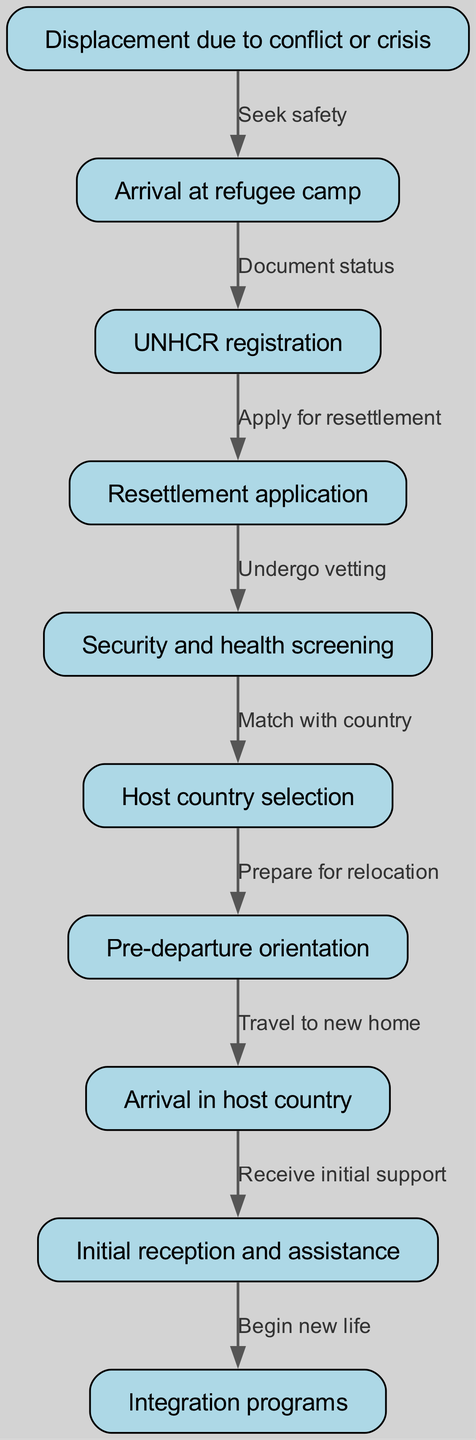What is the first step in the refugee resettlement process? The first step is "Displacement due to conflict or crisis," which is depicted as the starting node in the flowchart.
Answer: Displacement due to conflict or crisis How many nodes are in the diagram? By counting the entries in the nodes section of the data, there are 10 distinct nodes.
Answer: 10 What action follows "Arrival at refugee camp"? According to the flowchart, the action that follows is "UNHCR registration," as indicated by the arrow leading from the arrival node to this registration node.
Answer: UNHCR registration Which node represents the stage where refugees prepare for relocation? The node labeled "Pre-departure orientation" signifies the stage where refugees prepare for their upcoming move to a new country.
Answer: Pre-departure orientation What are the last two steps in the resettlement process? The last two steps in the flowchart are "Receive initial support" and "Begin new life," which are the final nodes in the sequence of actions.
Answer: Receive initial support and Begin new life How does a refugee transition from "Security and health screening" to "Host country selection"? After undergoing "Security and health screening," refugees are then matched with a host country, as shown in the edge connecting these two nodes.
Answer: Match with country What is required before submitting a resettlement application? The stage that must be completed before submitting a resettlement application is "UNHCR registration." This is inferred from the directional flow leading from registration to application.
Answer: UNHCR registration What is the relationship between "Arrival in host country" and "Initial reception and assistance"? The relationship is that upon arriving in the host country, refugees immediately receive "Initial reception and assistance," indicated by a direct connection from the arrival node to this support node.
Answer: Receive initial support How many edges are in the diagram? The edges represent the transitions between different nodes; the provided data reveals that there are 9 connections, corresponding to the flow of the resettlement process.
Answer: 9 